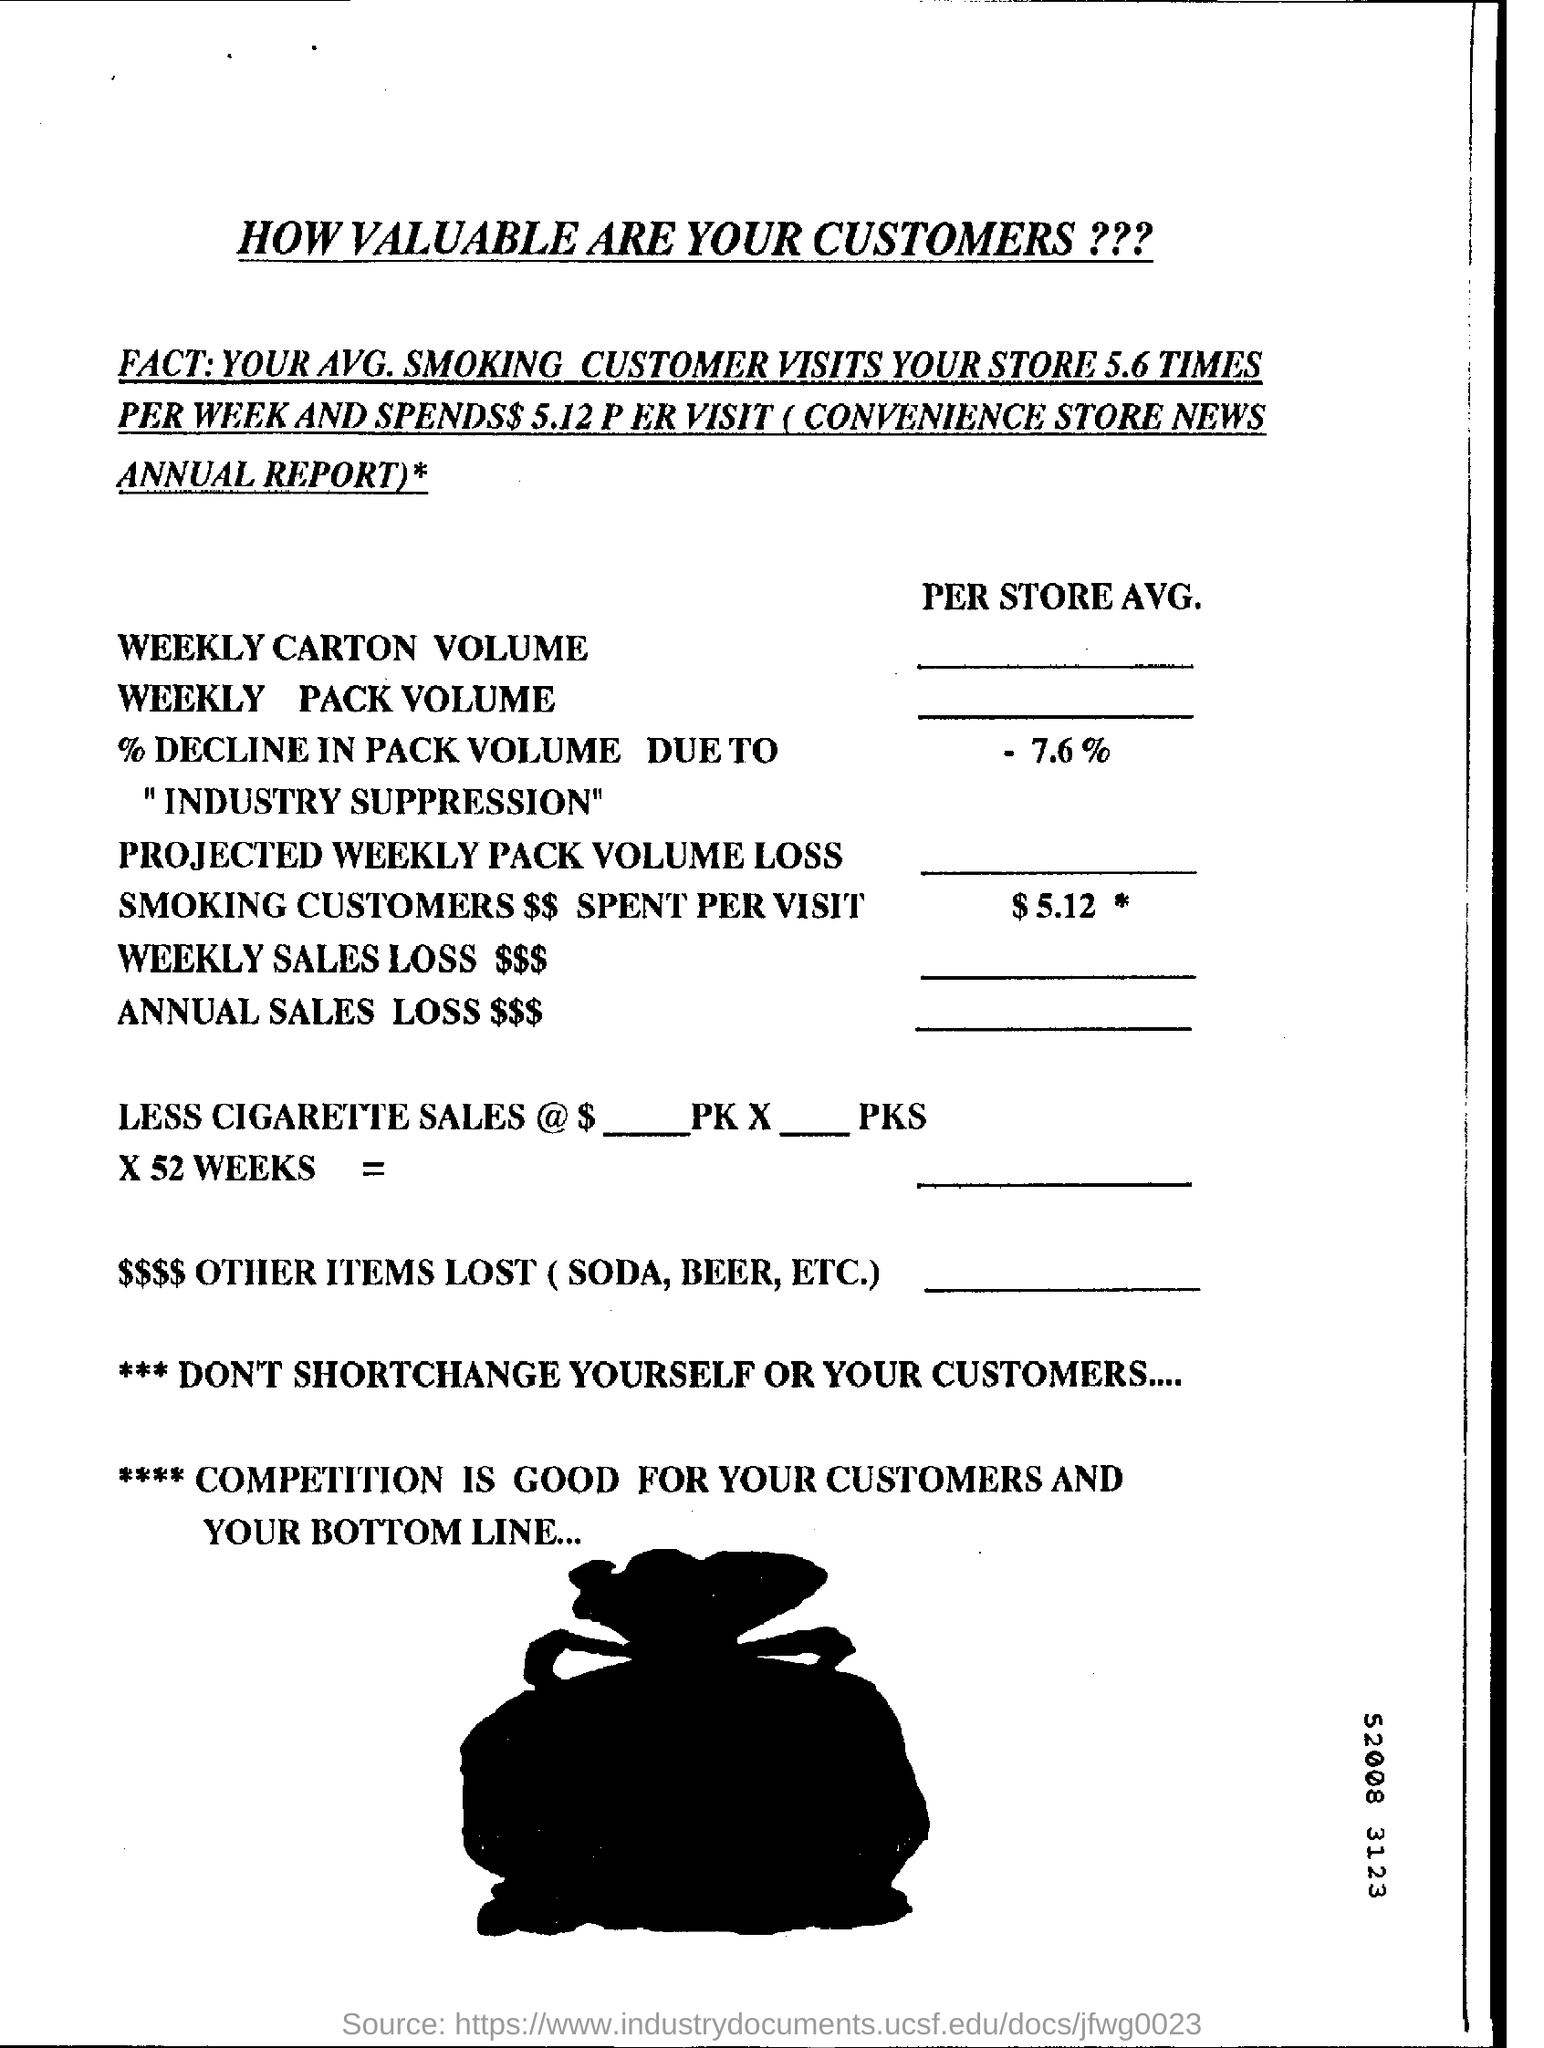What is the projected weekly pack volume loss smoking customers $$ spent per visit?
Offer a very short reply. 5.12. What is the value of % decline in pack volume due to "industry suppression"?
Offer a terse response. -7.6%. 